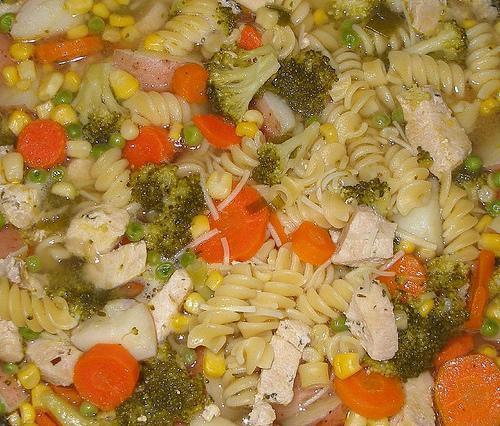How many vegetables are present in this dish?
Give a very brief answer. 4. 